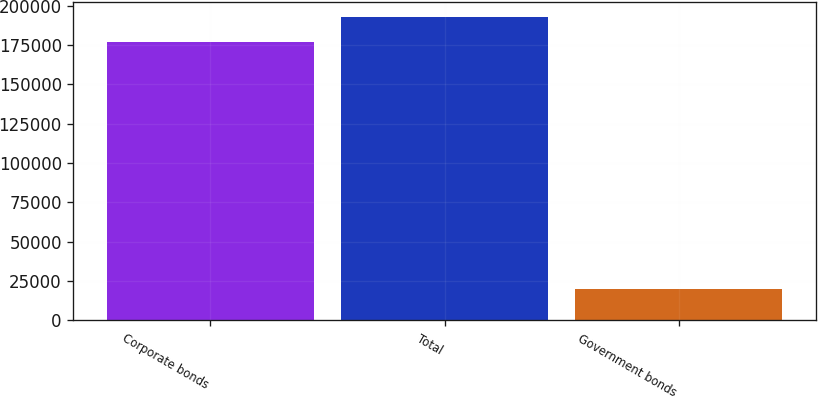<chart> <loc_0><loc_0><loc_500><loc_500><bar_chart><fcel>Corporate bonds<fcel>Total<fcel>Government bonds<nl><fcel>176845<fcel>192541<fcel>19884<nl></chart> 